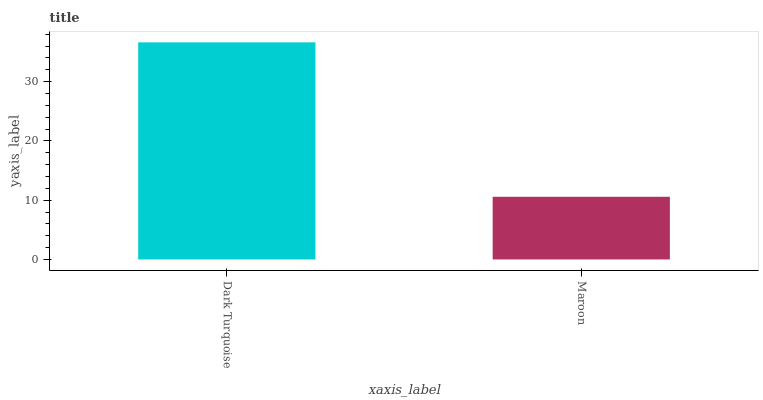Is Maroon the minimum?
Answer yes or no. Yes. Is Dark Turquoise the maximum?
Answer yes or no. Yes. Is Maroon the maximum?
Answer yes or no. No. Is Dark Turquoise greater than Maroon?
Answer yes or no. Yes. Is Maroon less than Dark Turquoise?
Answer yes or no. Yes. Is Maroon greater than Dark Turquoise?
Answer yes or no. No. Is Dark Turquoise less than Maroon?
Answer yes or no. No. Is Dark Turquoise the high median?
Answer yes or no. Yes. Is Maroon the low median?
Answer yes or no. Yes. Is Maroon the high median?
Answer yes or no. No. Is Dark Turquoise the low median?
Answer yes or no. No. 